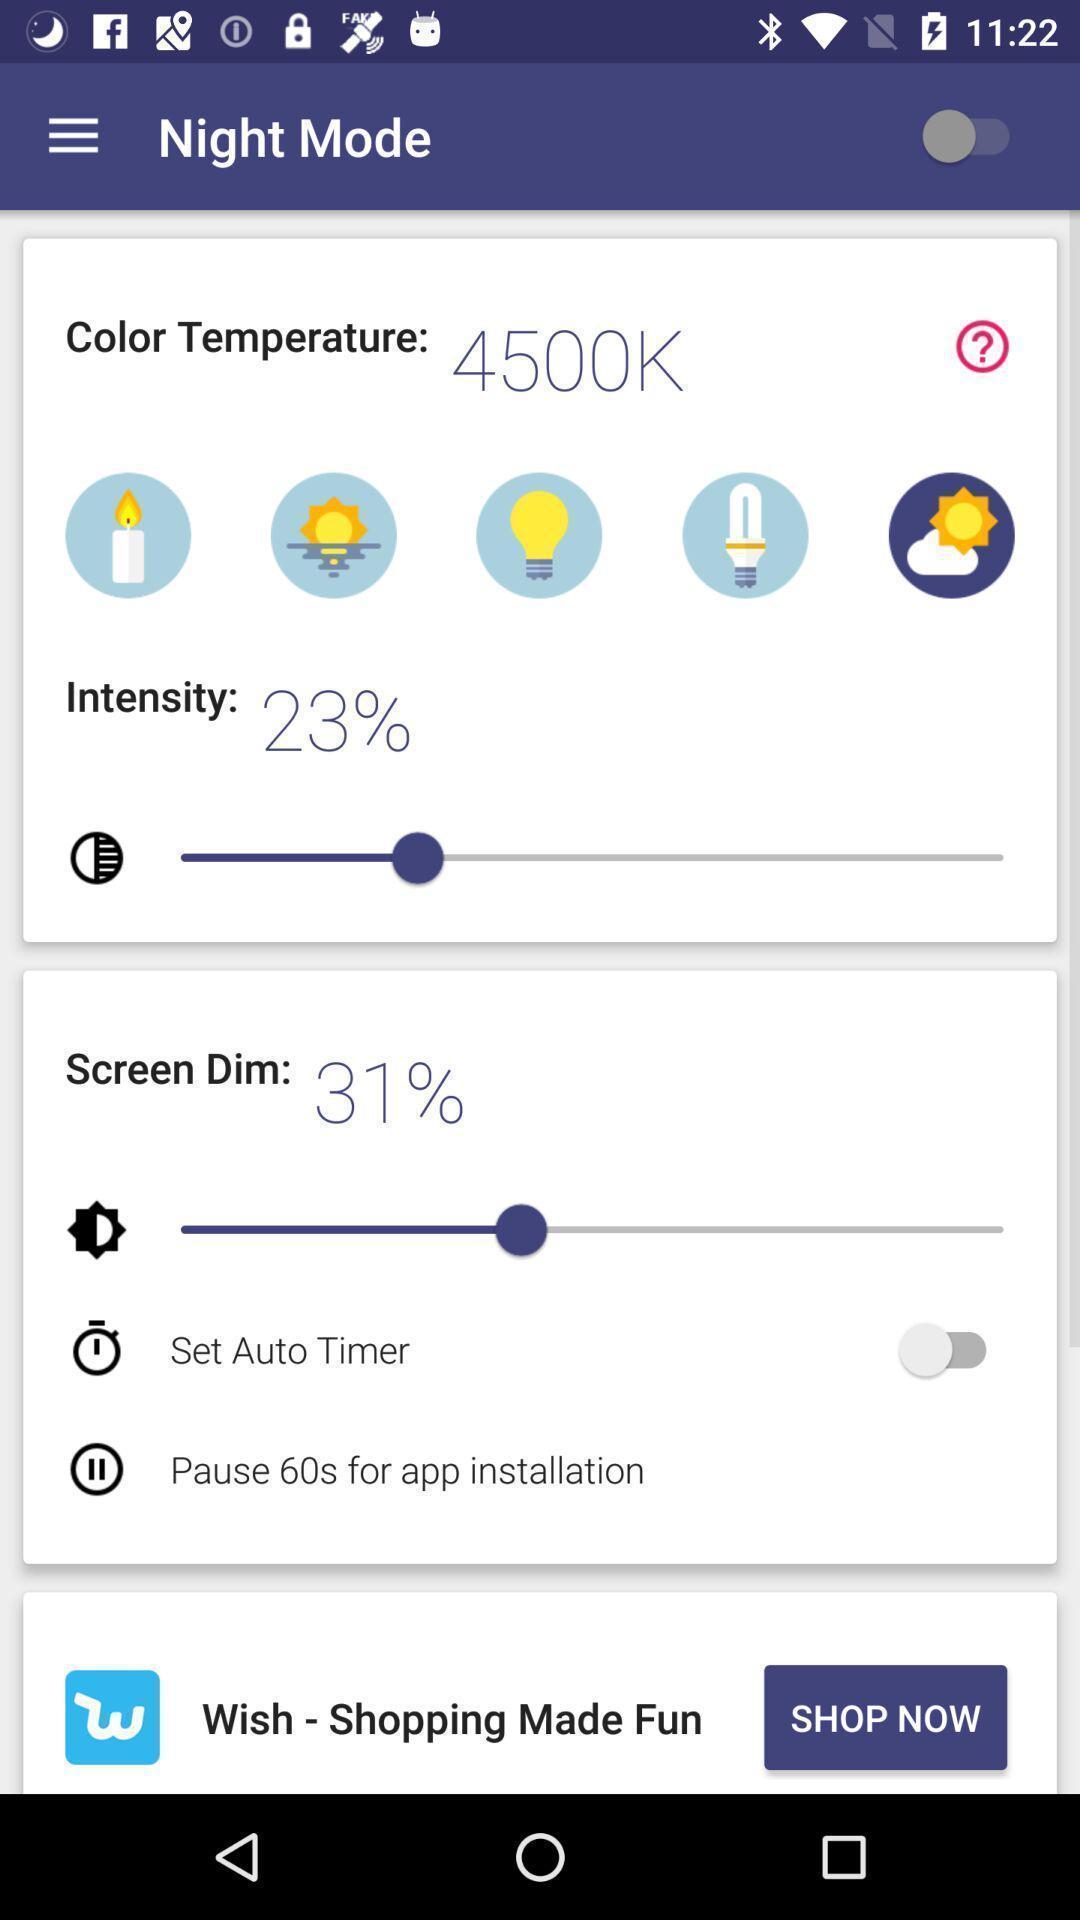What is the overall content of this screenshot? Screen displaying the night mode feature page. 